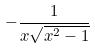<formula> <loc_0><loc_0><loc_500><loc_500>- \frac { 1 } { x \sqrt { x ^ { 2 } - 1 } }</formula> 